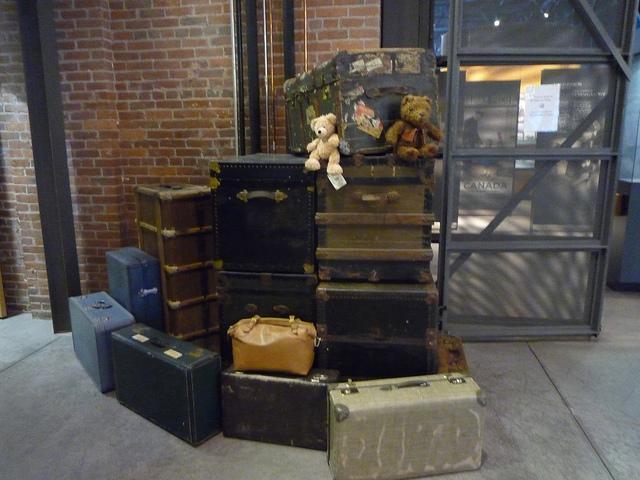What business is this display promoting?
Choose the right answer from the provided options to respond to the question.
Options: Nature trips, restaurant, travel agency, sporting goods. Travel agency. 